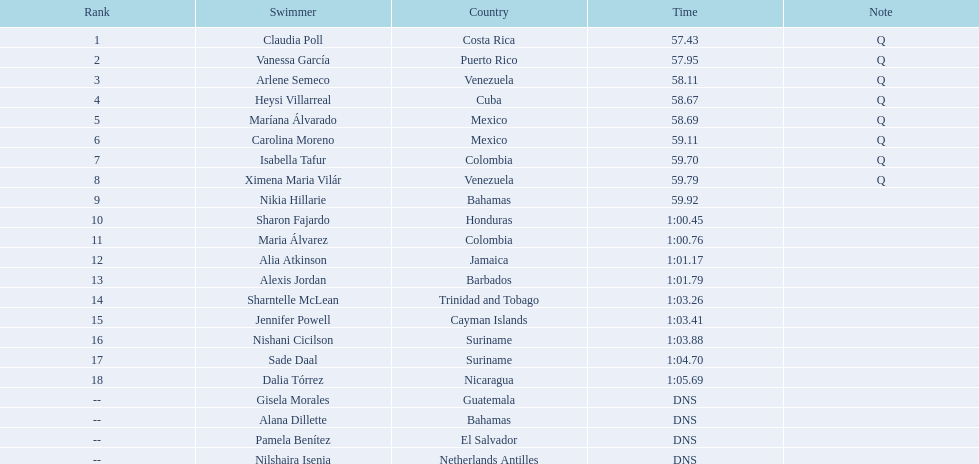Who took part in the women's 100m freestyle swimming competition at the 2006 central american and caribbean games? Claudia Poll, Vanessa García, Arlene Semeco, Heysi Villarreal, Maríana Álvarado, Carolina Moreno, Isabella Tafur, Ximena Maria Vilár, Nikia Hillarie, Sharon Fajardo, Maria Álvarez, Alia Atkinson, Alexis Jordan, Sharntelle McLean, Jennifer Powell, Nishani Cicilson, Sade Daal, Dalia Tórrez, Gisela Morales, Alana Dillette, Pamela Benítez, Nilshaira Isenia. Which of them represented cuba? Heysi Villarreal. Parse the full table. {'header': ['Rank', 'Swimmer', 'Country', 'Time', 'Note'], 'rows': [['1', 'Claudia Poll', 'Costa Rica', '57.43', 'Q'], ['2', 'Vanessa García', 'Puerto Rico', '57.95', 'Q'], ['3', 'Arlene Semeco', 'Venezuela', '58.11', 'Q'], ['4', 'Heysi Villarreal', 'Cuba', '58.67', 'Q'], ['5', 'Maríana Álvarado', 'Mexico', '58.69', 'Q'], ['6', 'Carolina Moreno', 'Mexico', '59.11', 'Q'], ['7', 'Isabella Tafur', 'Colombia', '59.70', 'Q'], ['8', 'Ximena Maria Vilár', 'Venezuela', '59.79', 'Q'], ['9', 'Nikia Hillarie', 'Bahamas', '59.92', ''], ['10', 'Sharon Fajardo', 'Honduras', '1:00.45', ''], ['11', 'Maria Álvarez', 'Colombia', '1:00.76', ''], ['12', 'Alia Atkinson', 'Jamaica', '1:01.17', ''], ['13', 'Alexis Jordan', 'Barbados', '1:01.79', ''], ['14', 'Sharntelle McLean', 'Trinidad and Tobago', '1:03.26', ''], ['15', 'Jennifer Powell', 'Cayman Islands', '1:03.41', ''], ['16', 'Nishani Cicilson', 'Suriname', '1:03.88', ''], ['17', 'Sade Daal', 'Suriname', '1:04.70', ''], ['18', 'Dalia Tórrez', 'Nicaragua', '1:05.69', ''], ['--', 'Gisela Morales', 'Guatemala', 'DNS', ''], ['--', 'Alana Dillette', 'Bahamas', 'DNS', ''], ['--', 'Pamela Benítez', 'El Salvador', 'DNS', ''], ['--', 'Nilshaira Isenia', 'Netherlands Antilles', 'DNS', '']]} 